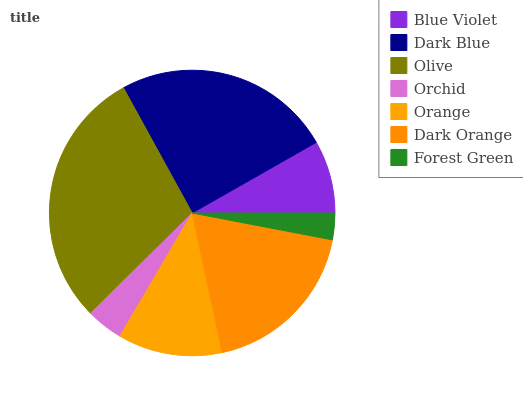Is Forest Green the minimum?
Answer yes or no. Yes. Is Olive the maximum?
Answer yes or no. Yes. Is Dark Blue the minimum?
Answer yes or no. No. Is Dark Blue the maximum?
Answer yes or no. No. Is Dark Blue greater than Blue Violet?
Answer yes or no. Yes. Is Blue Violet less than Dark Blue?
Answer yes or no. Yes. Is Blue Violet greater than Dark Blue?
Answer yes or no. No. Is Dark Blue less than Blue Violet?
Answer yes or no. No. Is Orange the high median?
Answer yes or no. Yes. Is Orange the low median?
Answer yes or no. Yes. Is Orchid the high median?
Answer yes or no. No. Is Blue Violet the low median?
Answer yes or no. No. 